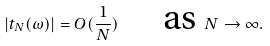Convert formula to latex. <formula><loc_0><loc_0><loc_500><loc_500>| t _ { N } ( \omega ) | = O ( \frac { 1 } { N } ) \text { \quad as } N \rightarrow \infty .</formula> 